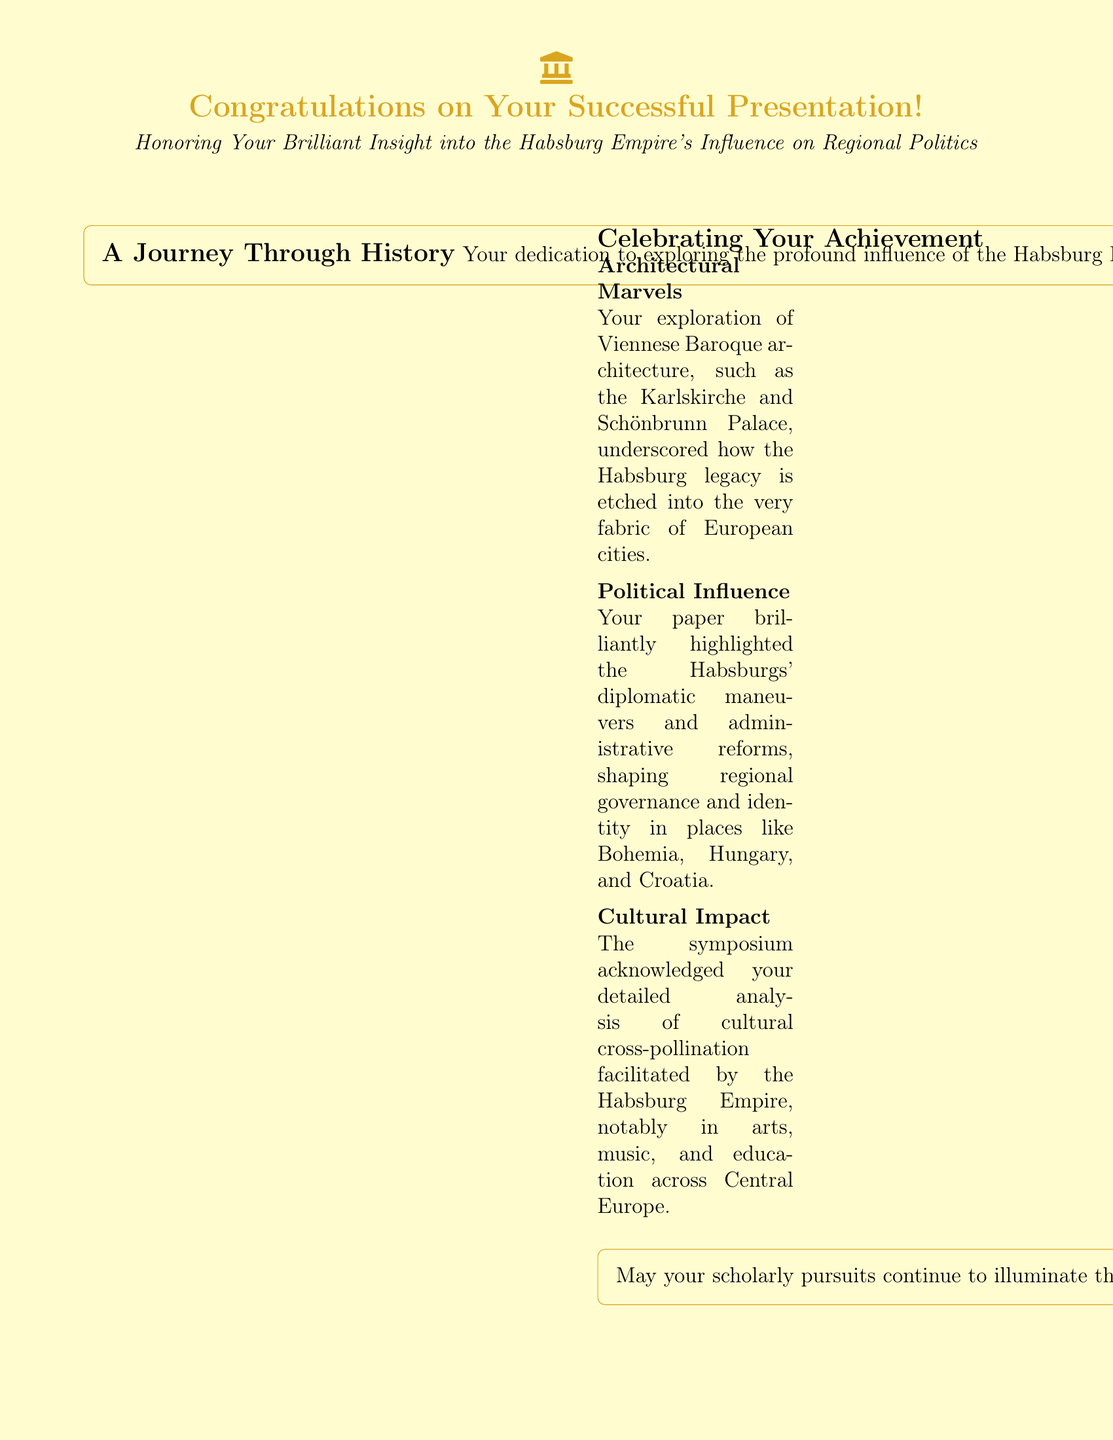What is the color of the accent used in the card? The accent color used in the card is defined as goldaccent in the document.
Answer: goldaccent What is the main achievement being celebrated in the card? The main achievement being celebrated is the successful presentation of a paper on the Habsburg Empire's influence on regional politics.
Answer: successful presentation Which architectural marvels are mentioned in the card? The architectural marvels mentioned in the card include Karlskirche and Schönbrunn Palace.
Answer: Karlskirche and Schönbrunn Palace Who is quoted in the document? The document features a quote from historian Pieter Judson discussing the impact of the Austro-Hungarian Monarchy.
Answer: Pieter Judson What is highlighted as an impact of the Habsburg Empire? The document highlights the cultural cross-pollination facilitated by the Habsburg Empire in various fields.
Answer: cultural cross-pollination What theme does the fancy box on the left side focus on? The left side of the document focuses on the theme of a journey through history related to the Habsburg Empire.
Answer: A Journey Through History How many columns are used in the layout of the card? The layout of the card uses two columns to organize the content effectively.
Answer: two columns What type of document is this? The type of document presented here is a greeting card, specifically aimed at celebrating an academic achievement.
Answer: greeting card 